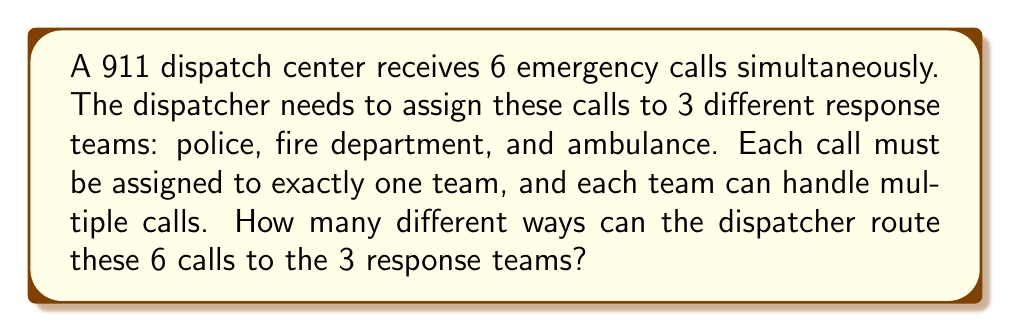Solve this math problem. To solve this problem, we need to use the concept of partitions in combinatorics. This is a case of distributing distinct objects (the 6 emergency calls) into distinct groups (the 3 response teams).

Let's approach this step-by-step:

1) Each call has 3 possible destinations (police, fire, or ambulance), and this choice is independent for each call.

2) This scenario can be modeled using the Multiplication Principle. For each call, we have 3 choices, and we make this choice 6 times (once for each call).

3) Therefore, the total number of ways to route the calls is:

   $$3 \times 3 \times 3 \times 3 \times 3 \times 3 = 3^6$$

4) We can simplify this:
   
   $$3^6 = 729$$

This result accounts for all possible distributions of the 6 calls among the 3 teams, including scenarios where some teams might not receive any calls, which is a valid outcome in this context.
Answer: $729$ ways 